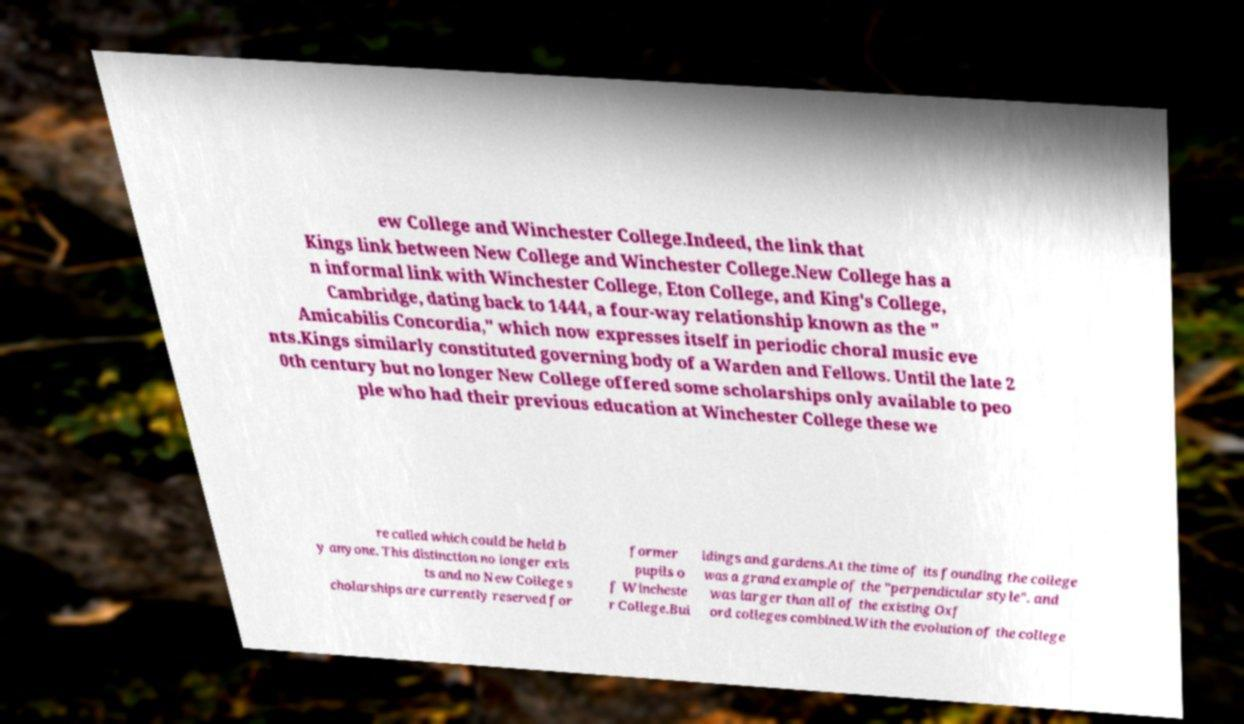Please identify and transcribe the text found in this image. ew College and Winchester College.Indeed, the link that Kings link between New College and Winchester College.New College has a n informal link with Winchester College, Eton College, and King's College, Cambridge, dating back to 1444, a four-way relationship known as the " Amicabilis Concordia," which now expresses itself in periodic choral music eve nts.Kings similarly constituted governing body of a Warden and Fellows. Until the late 2 0th century but no longer New College offered some scholarships only available to peo ple who had their previous education at Winchester College these we re called which could be held b y anyone. This distinction no longer exis ts and no New College s cholarships are currently reserved for former pupils o f Wincheste r College.Bui ldings and gardens.At the time of its founding the college was a grand example of the "perpendicular style". and was larger than all of the existing Oxf ord colleges combined.With the evolution of the college 